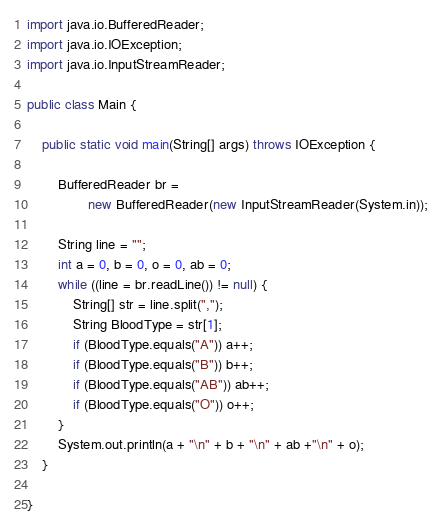Convert code to text. <code><loc_0><loc_0><loc_500><loc_500><_Java_>import java.io.BufferedReader;
import java.io.IOException;
import java.io.InputStreamReader;

public class Main {

	public static void main(String[] args) throws IOException {

		BufferedReader br =
				new BufferedReader(new InputStreamReader(System.in));

		String line = "";
		int a = 0, b = 0, o = 0, ab = 0;
		while ((line = br.readLine()) != null) {
			String[] str = line.split(",");
			String BloodType = str[1];
			if (BloodType.equals("A")) a++;
			if (BloodType.equals("B")) b++;
			if (BloodType.equals("AB")) ab++;
			if (BloodType.equals("O")) o++;
		}
		System.out.println(a + "\n" + b + "\n" + ab +"\n" + o);
	}

}</code> 